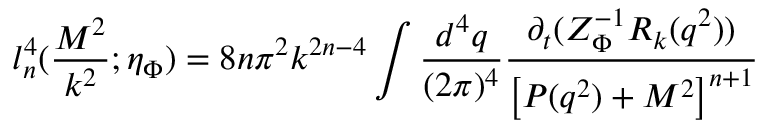<formula> <loc_0><loc_0><loc_500><loc_500>l _ { n } ^ { 4 } ( \frac { M ^ { 2 } } { k ^ { 2 } } ; \eta _ { \Phi } ) = 8 n \pi ^ { 2 } k ^ { 2 n - 4 } \int \frac { d ^ { 4 } q } { ( 2 \pi ) ^ { 4 } } \frac { \partial _ { t } ( Z _ { \Phi } ^ { - 1 } R _ { k } ( q ^ { 2 } ) ) } { \left [ P ( q ^ { 2 } ) + M ^ { 2 } \right ] ^ { n + 1 } }</formula> 